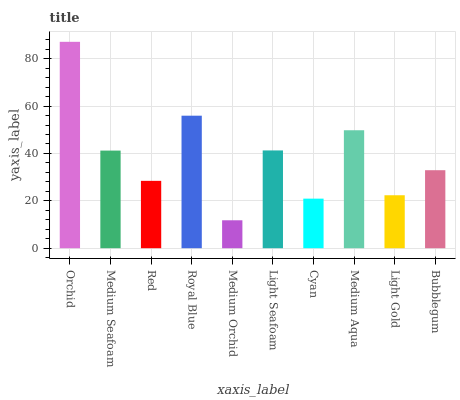Is Medium Orchid the minimum?
Answer yes or no. Yes. Is Orchid the maximum?
Answer yes or no. Yes. Is Medium Seafoam the minimum?
Answer yes or no. No. Is Medium Seafoam the maximum?
Answer yes or no. No. Is Orchid greater than Medium Seafoam?
Answer yes or no. Yes. Is Medium Seafoam less than Orchid?
Answer yes or no. Yes. Is Medium Seafoam greater than Orchid?
Answer yes or no. No. Is Orchid less than Medium Seafoam?
Answer yes or no. No. Is Medium Seafoam the high median?
Answer yes or no. Yes. Is Bubblegum the low median?
Answer yes or no. Yes. Is Medium Orchid the high median?
Answer yes or no. No. Is Cyan the low median?
Answer yes or no. No. 